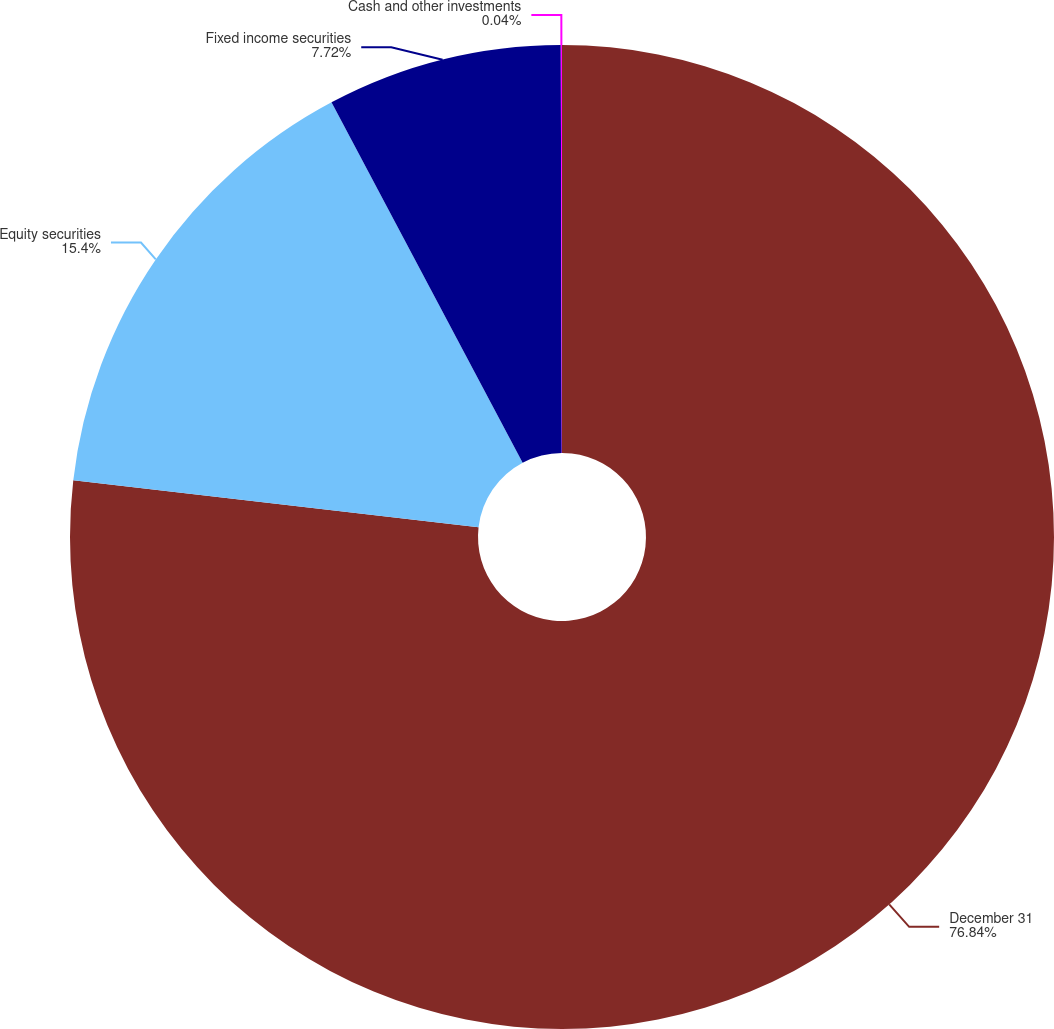Convert chart to OTSL. <chart><loc_0><loc_0><loc_500><loc_500><pie_chart><fcel>December 31<fcel>Equity securities<fcel>Fixed income securities<fcel>Cash and other investments<nl><fcel>76.84%<fcel>15.4%<fcel>7.72%<fcel>0.04%<nl></chart> 